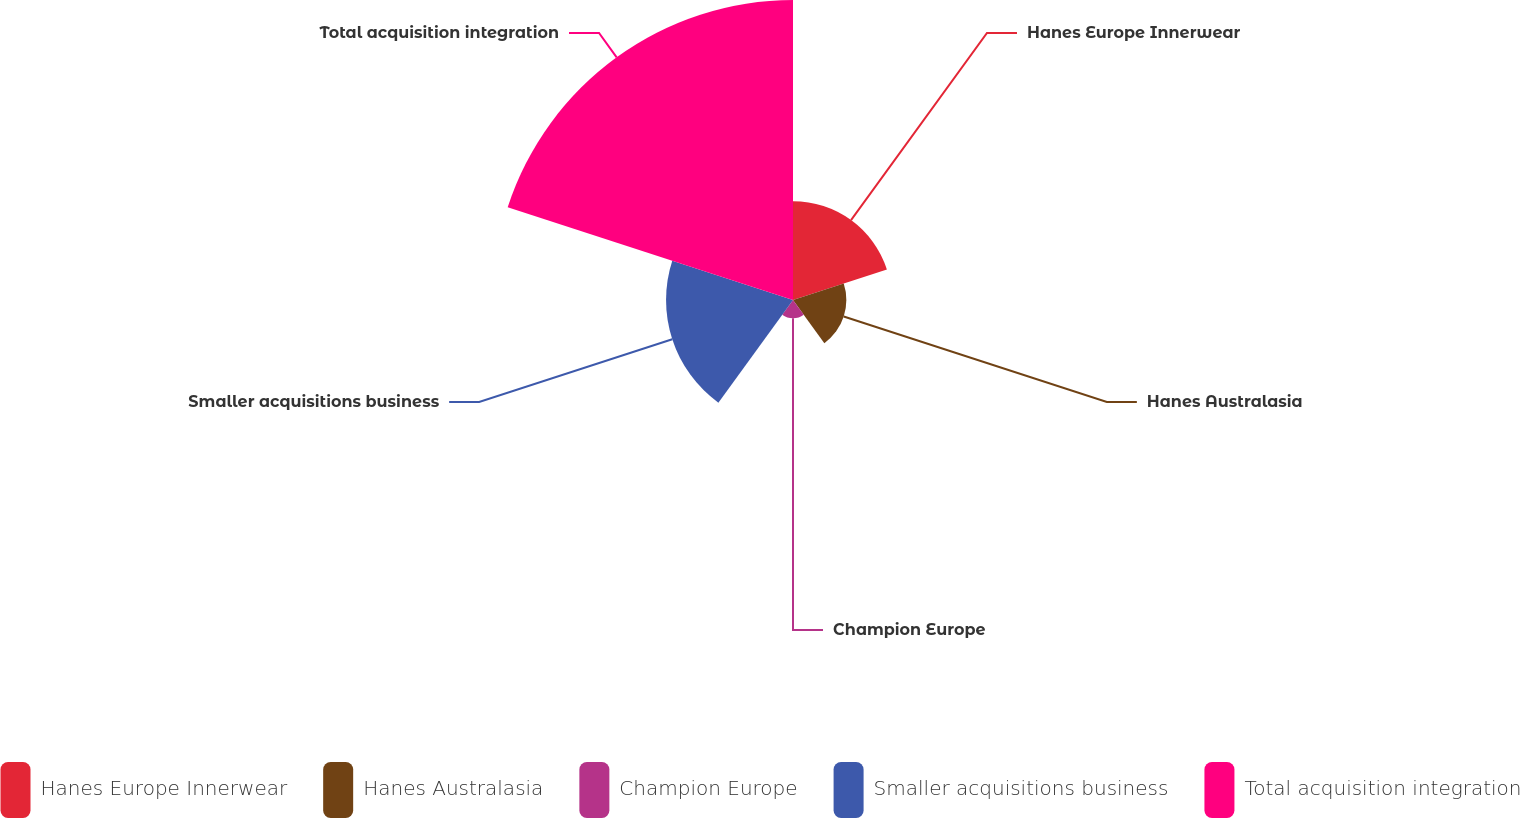Convert chart to OTSL. <chart><loc_0><loc_0><loc_500><loc_500><pie_chart><fcel>Hanes Europe Innerwear<fcel>Hanes Australasia<fcel>Champion Europe<fcel>Smaller acquisitions business<fcel>Total acquisition integration<nl><fcel>16.53%<fcel>8.93%<fcel>3.07%<fcel>21.25%<fcel>50.22%<nl></chart> 